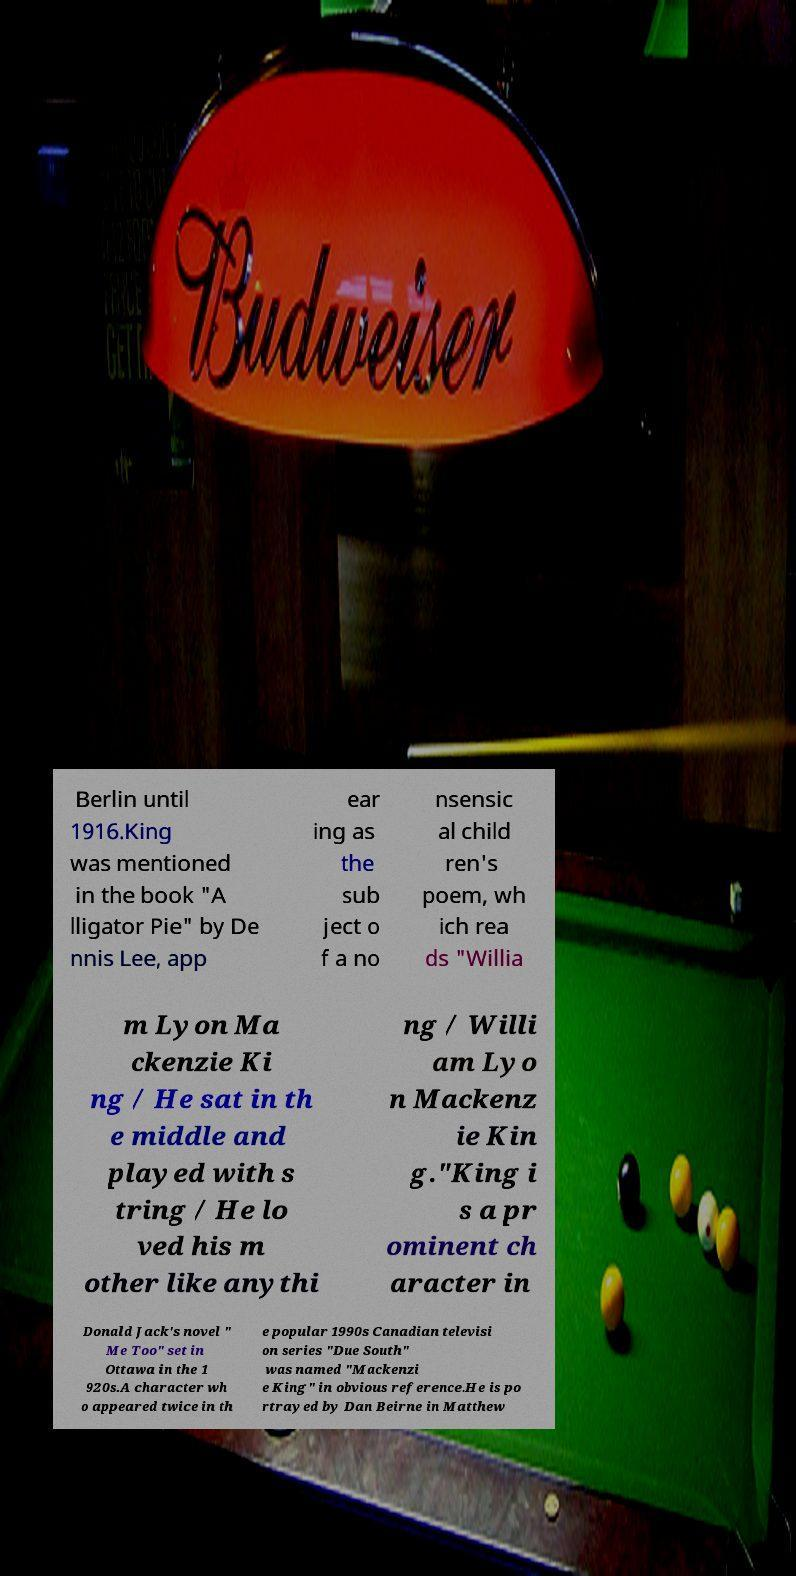Could you assist in decoding the text presented in this image and type it out clearly? Berlin until 1916.King was mentioned in the book "A lligator Pie" by De nnis Lee, app ear ing as the sub ject o f a no nsensic al child ren's poem, wh ich rea ds "Willia m Lyon Ma ckenzie Ki ng / He sat in th e middle and played with s tring / He lo ved his m other like anythi ng / Willi am Lyo n Mackenz ie Kin g."King i s a pr ominent ch aracter in Donald Jack's novel " Me Too" set in Ottawa in the 1 920s.A character wh o appeared twice in th e popular 1990s Canadian televisi on series "Due South" was named "Mackenzi e King" in obvious reference.He is po rtrayed by Dan Beirne in Matthew 